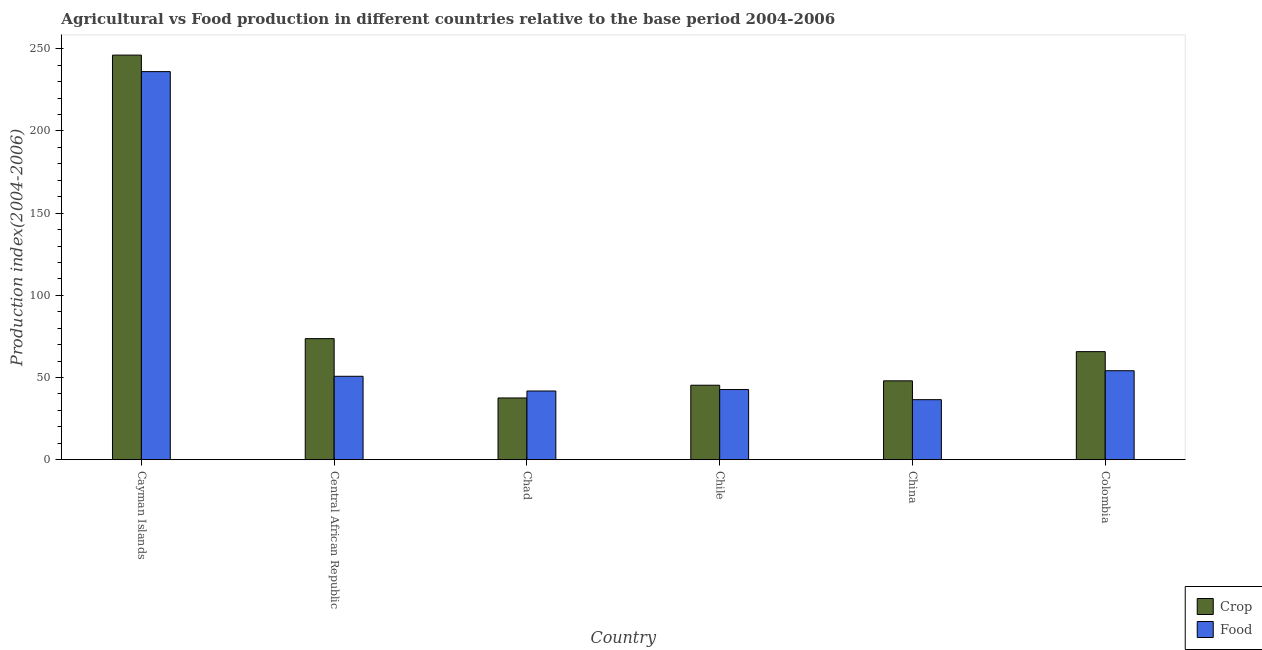How many different coloured bars are there?
Provide a succinct answer. 2. Are the number of bars per tick equal to the number of legend labels?
Provide a short and direct response. Yes. Are the number of bars on each tick of the X-axis equal?
Provide a succinct answer. Yes. How many bars are there on the 6th tick from the left?
Offer a very short reply. 2. What is the label of the 4th group of bars from the left?
Give a very brief answer. Chile. What is the crop production index in Chile?
Keep it short and to the point. 45.31. Across all countries, what is the maximum food production index?
Ensure brevity in your answer.  236.12. Across all countries, what is the minimum food production index?
Your answer should be very brief. 36.53. In which country was the food production index maximum?
Your answer should be compact. Cayman Islands. In which country was the crop production index minimum?
Keep it short and to the point. Chad. What is the total food production index in the graph?
Make the answer very short. 462.02. What is the difference between the crop production index in Cayman Islands and that in Chile?
Provide a short and direct response. 200.86. What is the difference between the food production index in Chad and the crop production index in Colombia?
Provide a short and direct response. -23.95. What is the average crop production index per country?
Offer a very short reply. 86.07. What is the difference between the food production index and crop production index in China?
Make the answer very short. -11.45. In how many countries, is the food production index greater than 30 ?
Make the answer very short. 6. What is the ratio of the food production index in Chad to that in Colombia?
Keep it short and to the point. 0.77. Is the crop production index in China less than that in Colombia?
Offer a terse response. Yes. Is the difference between the crop production index in Cayman Islands and Central African Republic greater than the difference between the food production index in Cayman Islands and Central African Republic?
Ensure brevity in your answer.  No. What is the difference between the highest and the second highest crop production index?
Give a very brief answer. 172.51. What is the difference between the highest and the lowest crop production index?
Make the answer very short. 208.61. In how many countries, is the crop production index greater than the average crop production index taken over all countries?
Provide a short and direct response. 1. Is the sum of the food production index in Cayman Islands and Colombia greater than the maximum crop production index across all countries?
Give a very brief answer. Yes. What does the 2nd bar from the left in China represents?
Your answer should be compact. Food. What does the 2nd bar from the right in Chad represents?
Keep it short and to the point. Crop. How many bars are there?
Ensure brevity in your answer.  12. Are all the bars in the graph horizontal?
Provide a short and direct response. No. What is the difference between two consecutive major ticks on the Y-axis?
Give a very brief answer. 50. Does the graph contain grids?
Give a very brief answer. No. How are the legend labels stacked?
Keep it short and to the point. Vertical. What is the title of the graph?
Provide a short and direct response. Agricultural vs Food production in different countries relative to the base period 2004-2006. Does "Working only" appear as one of the legend labels in the graph?
Give a very brief answer. No. What is the label or title of the Y-axis?
Your answer should be very brief. Production index(2004-2006). What is the Production index(2004-2006) in Crop in Cayman Islands?
Offer a terse response. 246.17. What is the Production index(2004-2006) of Food in Cayman Islands?
Ensure brevity in your answer.  236.12. What is the Production index(2004-2006) in Crop in Central African Republic?
Keep it short and to the point. 73.66. What is the Production index(2004-2006) in Food in Central African Republic?
Give a very brief answer. 50.75. What is the Production index(2004-2006) in Crop in Chad?
Offer a very short reply. 37.56. What is the Production index(2004-2006) in Food in Chad?
Your answer should be compact. 41.8. What is the Production index(2004-2006) of Crop in Chile?
Your answer should be compact. 45.31. What is the Production index(2004-2006) in Food in Chile?
Your response must be concise. 42.69. What is the Production index(2004-2006) of Crop in China?
Make the answer very short. 47.98. What is the Production index(2004-2006) in Food in China?
Keep it short and to the point. 36.53. What is the Production index(2004-2006) in Crop in Colombia?
Offer a terse response. 65.75. What is the Production index(2004-2006) of Food in Colombia?
Give a very brief answer. 54.13. Across all countries, what is the maximum Production index(2004-2006) of Crop?
Your answer should be very brief. 246.17. Across all countries, what is the maximum Production index(2004-2006) of Food?
Provide a succinct answer. 236.12. Across all countries, what is the minimum Production index(2004-2006) of Crop?
Offer a very short reply. 37.56. Across all countries, what is the minimum Production index(2004-2006) of Food?
Give a very brief answer. 36.53. What is the total Production index(2004-2006) of Crop in the graph?
Give a very brief answer. 516.43. What is the total Production index(2004-2006) in Food in the graph?
Offer a terse response. 462.02. What is the difference between the Production index(2004-2006) of Crop in Cayman Islands and that in Central African Republic?
Ensure brevity in your answer.  172.51. What is the difference between the Production index(2004-2006) in Food in Cayman Islands and that in Central African Republic?
Your response must be concise. 185.37. What is the difference between the Production index(2004-2006) of Crop in Cayman Islands and that in Chad?
Offer a terse response. 208.61. What is the difference between the Production index(2004-2006) in Food in Cayman Islands and that in Chad?
Your response must be concise. 194.32. What is the difference between the Production index(2004-2006) of Crop in Cayman Islands and that in Chile?
Your response must be concise. 200.86. What is the difference between the Production index(2004-2006) in Food in Cayman Islands and that in Chile?
Keep it short and to the point. 193.43. What is the difference between the Production index(2004-2006) of Crop in Cayman Islands and that in China?
Keep it short and to the point. 198.19. What is the difference between the Production index(2004-2006) in Food in Cayman Islands and that in China?
Provide a succinct answer. 199.59. What is the difference between the Production index(2004-2006) of Crop in Cayman Islands and that in Colombia?
Your answer should be very brief. 180.42. What is the difference between the Production index(2004-2006) of Food in Cayman Islands and that in Colombia?
Keep it short and to the point. 181.99. What is the difference between the Production index(2004-2006) of Crop in Central African Republic and that in Chad?
Offer a very short reply. 36.1. What is the difference between the Production index(2004-2006) in Food in Central African Republic and that in Chad?
Provide a short and direct response. 8.95. What is the difference between the Production index(2004-2006) in Crop in Central African Republic and that in Chile?
Offer a very short reply. 28.35. What is the difference between the Production index(2004-2006) of Food in Central African Republic and that in Chile?
Provide a succinct answer. 8.06. What is the difference between the Production index(2004-2006) in Crop in Central African Republic and that in China?
Give a very brief answer. 25.68. What is the difference between the Production index(2004-2006) in Food in Central African Republic and that in China?
Provide a succinct answer. 14.22. What is the difference between the Production index(2004-2006) in Crop in Central African Republic and that in Colombia?
Make the answer very short. 7.91. What is the difference between the Production index(2004-2006) of Food in Central African Republic and that in Colombia?
Keep it short and to the point. -3.38. What is the difference between the Production index(2004-2006) in Crop in Chad and that in Chile?
Provide a short and direct response. -7.75. What is the difference between the Production index(2004-2006) in Food in Chad and that in Chile?
Ensure brevity in your answer.  -0.89. What is the difference between the Production index(2004-2006) in Crop in Chad and that in China?
Your answer should be very brief. -10.42. What is the difference between the Production index(2004-2006) of Food in Chad and that in China?
Your response must be concise. 5.27. What is the difference between the Production index(2004-2006) of Crop in Chad and that in Colombia?
Your response must be concise. -28.19. What is the difference between the Production index(2004-2006) of Food in Chad and that in Colombia?
Make the answer very short. -12.33. What is the difference between the Production index(2004-2006) of Crop in Chile and that in China?
Make the answer very short. -2.67. What is the difference between the Production index(2004-2006) in Food in Chile and that in China?
Keep it short and to the point. 6.16. What is the difference between the Production index(2004-2006) in Crop in Chile and that in Colombia?
Your response must be concise. -20.44. What is the difference between the Production index(2004-2006) in Food in Chile and that in Colombia?
Give a very brief answer. -11.44. What is the difference between the Production index(2004-2006) of Crop in China and that in Colombia?
Your answer should be very brief. -17.77. What is the difference between the Production index(2004-2006) of Food in China and that in Colombia?
Your answer should be very brief. -17.6. What is the difference between the Production index(2004-2006) in Crop in Cayman Islands and the Production index(2004-2006) in Food in Central African Republic?
Provide a succinct answer. 195.42. What is the difference between the Production index(2004-2006) in Crop in Cayman Islands and the Production index(2004-2006) in Food in Chad?
Give a very brief answer. 204.37. What is the difference between the Production index(2004-2006) of Crop in Cayman Islands and the Production index(2004-2006) of Food in Chile?
Offer a very short reply. 203.48. What is the difference between the Production index(2004-2006) of Crop in Cayman Islands and the Production index(2004-2006) of Food in China?
Your answer should be compact. 209.64. What is the difference between the Production index(2004-2006) in Crop in Cayman Islands and the Production index(2004-2006) in Food in Colombia?
Your answer should be very brief. 192.04. What is the difference between the Production index(2004-2006) of Crop in Central African Republic and the Production index(2004-2006) of Food in Chad?
Give a very brief answer. 31.86. What is the difference between the Production index(2004-2006) in Crop in Central African Republic and the Production index(2004-2006) in Food in Chile?
Provide a succinct answer. 30.97. What is the difference between the Production index(2004-2006) in Crop in Central African Republic and the Production index(2004-2006) in Food in China?
Offer a terse response. 37.13. What is the difference between the Production index(2004-2006) of Crop in Central African Republic and the Production index(2004-2006) of Food in Colombia?
Your answer should be compact. 19.53. What is the difference between the Production index(2004-2006) of Crop in Chad and the Production index(2004-2006) of Food in Chile?
Ensure brevity in your answer.  -5.13. What is the difference between the Production index(2004-2006) of Crop in Chad and the Production index(2004-2006) of Food in Colombia?
Your response must be concise. -16.57. What is the difference between the Production index(2004-2006) in Crop in Chile and the Production index(2004-2006) in Food in China?
Your answer should be very brief. 8.78. What is the difference between the Production index(2004-2006) of Crop in Chile and the Production index(2004-2006) of Food in Colombia?
Provide a succinct answer. -8.82. What is the difference between the Production index(2004-2006) of Crop in China and the Production index(2004-2006) of Food in Colombia?
Ensure brevity in your answer.  -6.15. What is the average Production index(2004-2006) of Crop per country?
Give a very brief answer. 86.07. What is the average Production index(2004-2006) in Food per country?
Offer a very short reply. 77. What is the difference between the Production index(2004-2006) of Crop and Production index(2004-2006) of Food in Cayman Islands?
Your answer should be compact. 10.05. What is the difference between the Production index(2004-2006) of Crop and Production index(2004-2006) of Food in Central African Republic?
Ensure brevity in your answer.  22.91. What is the difference between the Production index(2004-2006) in Crop and Production index(2004-2006) in Food in Chad?
Ensure brevity in your answer.  -4.24. What is the difference between the Production index(2004-2006) of Crop and Production index(2004-2006) of Food in Chile?
Give a very brief answer. 2.62. What is the difference between the Production index(2004-2006) in Crop and Production index(2004-2006) in Food in China?
Make the answer very short. 11.45. What is the difference between the Production index(2004-2006) in Crop and Production index(2004-2006) in Food in Colombia?
Keep it short and to the point. 11.62. What is the ratio of the Production index(2004-2006) in Crop in Cayman Islands to that in Central African Republic?
Keep it short and to the point. 3.34. What is the ratio of the Production index(2004-2006) of Food in Cayman Islands to that in Central African Republic?
Your answer should be very brief. 4.65. What is the ratio of the Production index(2004-2006) in Crop in Cayman Islands to that in Chad?
Your answer should be very brief. 6.55. What is the ratio of the Production index(2004-2006) of Food in Cayman Islands to that in Chad?
Offer a terse response. 5.65. What is the ratio of the Production index(2004-2006) of Crop in Cayman Islands to that in Chile?
Make the answer very short. 5.43. What is the ratio of the Production index(2004-2006) in Food in Cayman Islands to that in Chile?
Provide a short and direct response. 5.53. What is the ratio of the Production index(2004-2006) of Crop in Cayman Islands to that in China?
Ensure brevity in your answer.  5.13. What is the ratio of the Production index(2004-2006) of Food in Cayman Islands to that in China?
Offer a terse response. 6.46. What is the ratio of the Production index(2004-2006) of Crop in Cayman Islands to that in Colombia?
Give a very brief answer. 3.74. What is the ratio of the Production index(2004-2006) in Food in Cayman Islands to that in Colombia?
Provide a short and direct response. 4.36. What is the ratio of the Production index(2004-2006) of Crop in Central African Republic to that in Chad?
Provide a succinct answer. 1.96. What is the ratio of the Production index(2004-2006) of Food in Central African Republic to that in Chad?
Give a very brief answer. 1.21. What is the ratio of the Production index(2004-2006) in Crop in Central African Republic to that in Chile?
Provide a short and direct response. 1.63. What is the ratio of the Production index(2004-2006) of Food in Central African Republic to that in Chile?
Give a very brief answer. 1.19. What is the ratio of the Production index(2004-2006) of Crop in Central African Republic to that in China?
Keep it short and to the point. 1.54. What is the ratio of the Production index(2004-2006) of Food in Central African Republic to that in China?
Your answer should be compact. 1.39. What is the ratio of the Production index(2004-2006) in Crop in Central African Republic to that in Colombia?
Make the answer very short. 1.12. What is the ratio of the Production index(2004-2006) of Food in Central African Republic to that in Colombia?
Provide a short and direct response. 0.94. What is the ratio of the Production index(2004-2006) in Crop in Chad to that in Chile?
Provide a succinct answer. 0.83. What is the ratio of the Production index(2004-2006) of Food in Chad to that in Chile?
Provide a short and direct response. 0.98. What is the ratio of the Production index(2004-2006) in Crop in Chad to that in China?
Offer a terse response. 0.78. What is the ratio of the Production index(2004-2006) in Food in Chad to that in China?
Keep it short and to the point. 1.14. What is the ratio of the Production index(2004-2006) of Crop in Chad to that in Colombia?
Your answer should be very brief. 0.57. What is the ratio of the Production index(2004-2006) of Food in Chad to that in Colombia?
Make the answer very short. 0.77. What is the ratio of the Production index(2004-2006) in Crop in Chile to that in China?
Your response must be concise. 0.94. What is the ratio of the Production index(2004-2006) in Food in Chile to that in China?
Offer a very short reply. 1.17. What is the ratio of the Production index(2004-2006) of Crop in Chile to that in Colombia?
Make the answer very short. 0.69. What is the ratio of the Production index(2004-2006) of Food in Chile to that in Colombia?
Your response must be concise. 0.79. What is the ratio of the Production index(2004-2006) of Crop in China to that in Colombia?
Make the answer very short. 0.73. What is the ratio of the Production index(2004-2006) of Food in China to that in Colombia?
Make the answer very short. 0.67. What is the difference between the highest and the second highest Production index(2004-2006) of Crop?
Your answer should be compact. 172.51. What is the difference between the highest and the second highest Production index(2004-2006) of Food?
Provide a succinct answer. 181.99. What is the difference between the highest and the lowest Production index(2004-2006) in Crop?
Make the answer very short. 208.61. What is the difference between the highest and the lowest Production index(2004-2006) of Food?
Your answer should be compact. 199.59. 